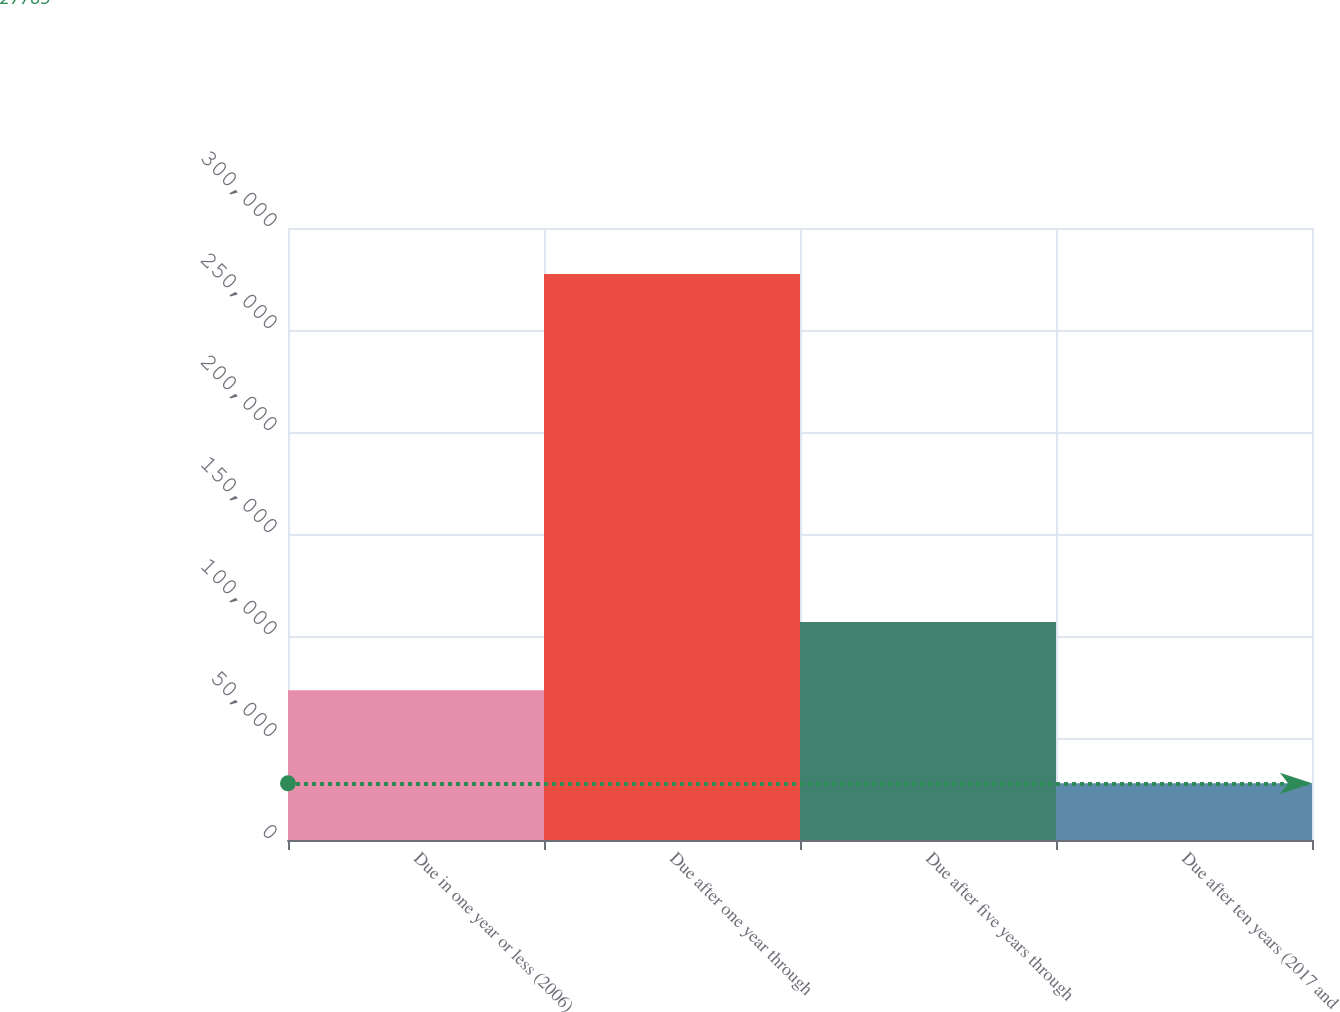<chart> <loc_0><loc_0><loc_500><loc_500><bar_chart><fcel>Due in one year or less (2006)<fcel>Due after one year through<fcel>Due after five years through<fcel>Due after ten years (2017 and<nl><fcel>73398<fcel>277510<fcel>106917<fcel>27785<nl></chart> 